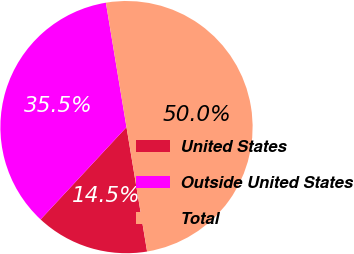Convert chart. <chart><loc_0><loc_0><loc_500><loc_500><pie_chart><fcel>United States<fcel>Outside United States<fcel>Total<nl><fcel>14.54%<fcel>35.46%<fcel>50.0%<nl></chart> 